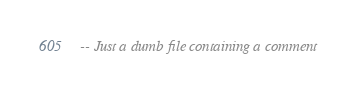Convert code to text. <code><loc_0><loc_0><loc_500><loc_500><_SQL_>-- Just a dumb file containing a comment
</code> 